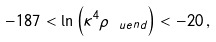<formula> <loc_0><loc_0><loc_500><loc_500>- 1 8 7 < \ln \left ( \kappa ^ { 4 } \rho _ { \ u e n d } \right ) < - 2 0 \, ,</formula> 